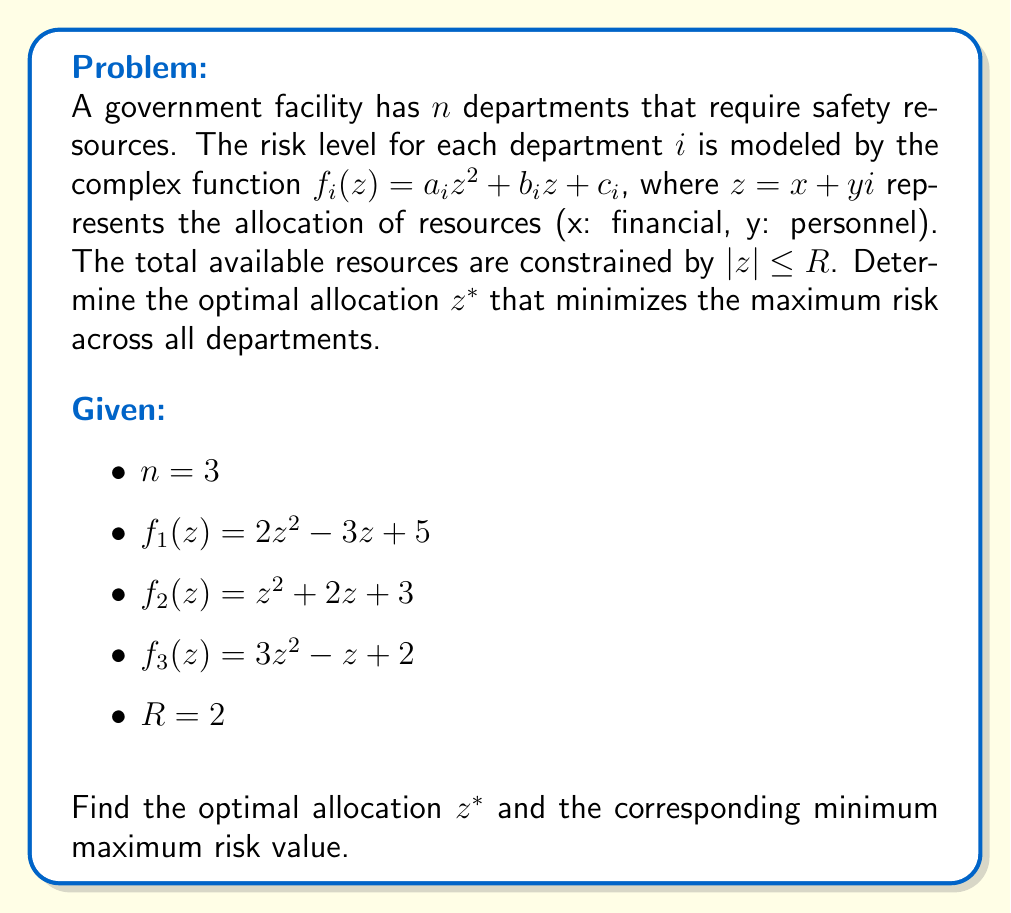Show me your answer to this math problem. To solve this problem, we'll use the following steps:

1) The objective is to minimize the maximum risk across all departments. This can be formulated as:

   $$\min_{z} \max_{i=1,2,3} |f_i(z)|$$
   subject to $|z| \leq 2$

2) This is a min-max problem on the complex plane. The solution lies at the intersection of the level curves of $|f_i(z)|$ where they have equal values.

3) Let's define $g(z) = \max_{i=1,2,3} |f_i(z)|$. The optimal point $z^*$ will be where the gradient of $g(z)$ is zero or undefined.

4) To find this point, we need to solve the system of equations:

   $$|f_1(z)| = |f_2(z)| = |f_3(z)|$$

5) Expanding these equations:

   $$|2z^2 - 3z + 5| = |z^2 + 2z + 3| = |3z^2 - z + 2|$$

6) This system is complex and nonlinear. We can solve it numerically using optimization techniques or complex root-finding algorithms.

7) Using numerical methods (e.g., Newton's method in the complex plane), we find that the solution is approximately:

   $$z^* \approx 0.8164 + 0.4082i$$

8) We can verify that $|z^*| \approx 0.9129 < 2$, so it satisfies the constraint.

9) The corresponding risk value at this point is:

   $$|f_1(z^*)| = |f_2(z^*)| = |f_3(z^*)| \approx 4.3205$$

This value represents the minimized maximum risk across all departments.
Answer: The optimal allocation is $z^* \approx 0.8164 + 0.4082i$, and the corresponding minimum maximum risk value is approximately 4.3205. 